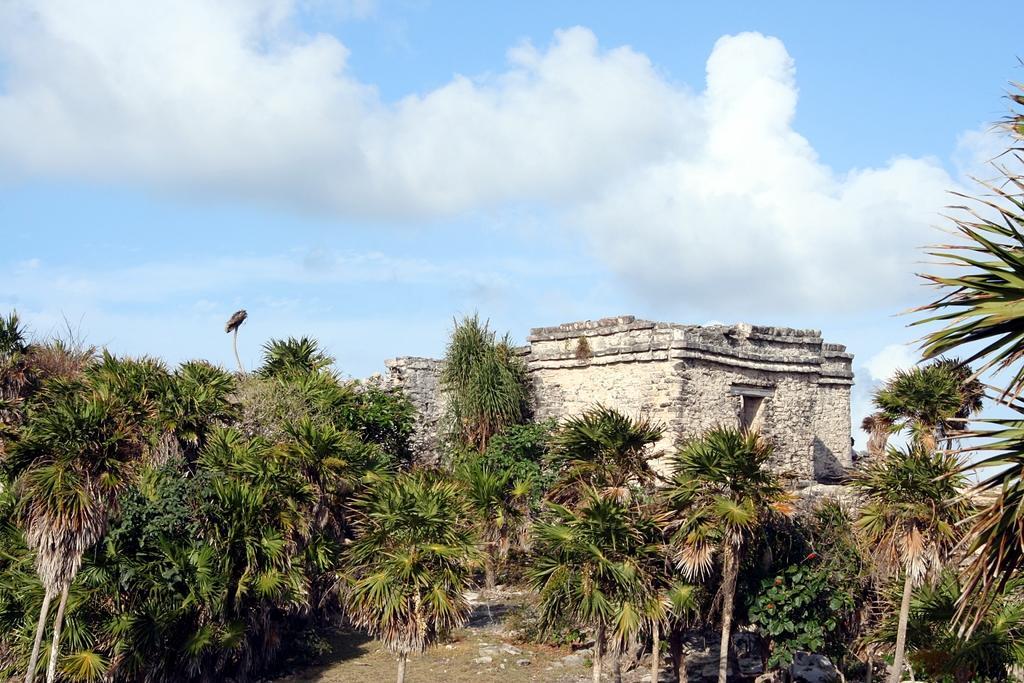Can you describe this image briefly? At the bottom of the picture, there are trees. Behind that, we see a building made up of stones. At the top of the picture, we see the sky and the clouds. 